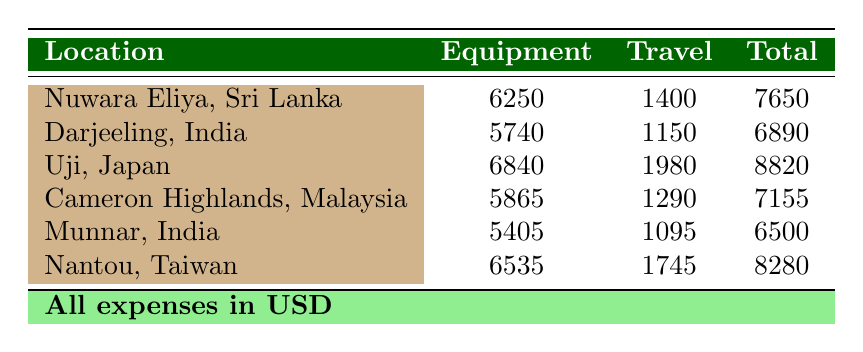What is the total equipment expense for Uji, Japan? The table specifically states that the total equipment expense for Uji, Japan is listed in the corresponding row under the Equipment column. By looking at that row, the value is 6840.
Answer: 6840 What is the travel expense for Munnar, India? By examining the row for Munnar, India, we can find the travel expense listed under the Travel column, which is 1095.
Answer: 1095 Which location has the highest total expenses? To determine the location with the highest total expenses, we compare the values in the Total column. Uji, Japan has the highest total expenses at 8820.
Answer: Uji, Japan What is the total combined expense for equipment and travel for Nuwara Eliya, Sri Lanka? The combined expense can be computed by adding the total equipment expense (6250) and total travel expense (1400) listed under Nuwara Eliya. The calculation is 6250 + 1400 = 7650.
Answer: 7650 Is the travel expense for Cameron Highlands, Malaysia higher than that for Darjeeling, India? The travel expense for Cameron Highlands is 1290, while for Darjeeling, it is 1150. Comparing the two values shows that 1290 is greater than 1150, confirming that Cameron Highlands has a higher travel expense.
Answer: Yes What is the average total expense across all locations? To find the average total expense, first sum all total expenses: 7650 + 6890 + 8820 + 7155 + 6500 + 8280 = 37895. Then divide by the number of locations (6): 37895 / 6 = 6315.83, which rounds to approximately 6316.
Answer: 6316 Does Nantou, Taiwan have a higher travel expense than Uji, Japan? The travel expense for Nantou is 1745 and for Uji is 1980. Since 1745 is less than 1980, Nantou does not have a higher travel expense than Uji.
Answer: No What is the difference in total expenses between Nuwara Eliya, Sri Lanka and Cameron Highlands, Malaysia? The total expenses for Nuwara Eliya are 7650 and for Cameron Highlands are 7155. To find the difference, subtract: 7650 - 7155 = 495.
Answer: 495 What is the total expense for equipment and travel combined for all locations? We need to sum the total expenses for each location: 7650 + 6890 + 8820 + 7155 + 6500 + 8280 = 37895. Therefore, the total expense for all locations combined is 37895.
Answer: 37895 